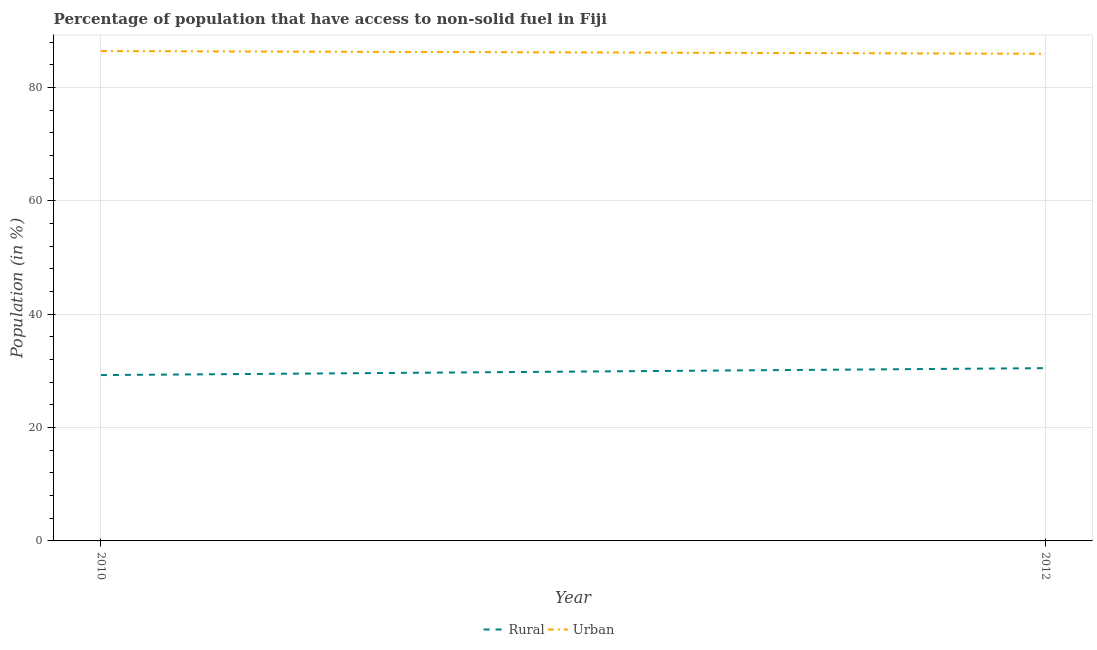How many different coloured lines are there?
Your response must be concise. 2. Does the line corresponding to urban population intersect with the line corresponding to rural population?
Offer a very short reply. No. What is the rural population in 2012?
Provide a succinct answer. 30.49. Across all years, what is the maximum urban population?
Ensure brevity in your answer.  86.44. Across all years, what is the minimum rural population?
Give a very brief answer. 29.26. What is the total rural population in the graph?
Ensure brevity in your answer.  59.75. What is the difference between the rural population in 2010 and that in 2012?
Provide a short and direct response. -1.22. What is the difference between the urban population in 2012 and the rural population in 2010?
Give a very brief answer. 56.7. What is the average rural population per year?
Your answer should be compact. 29.88. In the year 2010, what is the difference between the urban population and rural population?
Give a very brief answer. 57.17. In how many years, is the rural population greater than 16 %?
Give a very brief answer. 2. What is the ratio of the urban population in 2010 to that in 2012?
Ensure brevity in your answer.  1.01. Is the urban population in 2010 less than that in 2012?
Provide a succinct answer. No. In how many years, is the urban population greater than the average urban population taken over all years?
Offer a terse response. 1. Is the urban population strictly less than the rural population over the years?
Ensure brevity in your answer.  No. How many lines are there?
Offer a terse response. 2. How many years are there in the graph?
Ensure brevity in your answer.  2. Are the values on the major ticks of Y-axis written in scientific E-notation?
Provide a short and direct response. No. Does the graph contain grids?
Provide a short and direct response. Yes. How are the legend labels stacked?
Your answer should be compact. Horizontal. What is the title of the graph?
Ensure brevity in your answer.  Percentage of population that have access to non-solid fuel in Fiji. Does "Start a business" appear as one of the legend labels in the graph?
Your answer should be very brief. No. What is the label or title of the Y-axis?
Your answer should be compact. Population (in %). What is the Population (in %) in Rural in 2010?
Ensure brevity in your answer.  29.26. What is the Population (in %) of Urban in 2010?
Make the answer very short. 86.44. What is the Population (in %) of Rural in 2012?
Offer a very short reply. 30.49. What is the Population (in %) of Urban in 2012?
Provide a short and direct response. 85.97. Across all years, what is the maximum Population (in %) in Rural?
Your response must be concise. 30.49. Across all years, what is the maximum Population (in %) of Urban?
Make the answer very short. 86.44. Across all years, what is the minimum Population (in %) of Rural?
Offer a terse response. 29.26. Across all years, what is the minimum Population (in %) in Urban?
Offer a very short reply. 85.97. What is the total Population (in %) in Rural in the graph?
Provide a short and direct response. 59.75. What is the total Population (in %) of Urban in the graph?
Ensure brevity in your answer.  172.41. What is the difference between the Population (in %) of Rural in 2010 and that in 2012?
Give a very brief answer. -1.22. What is the difference between the Population (in %) in Urban in 2010 and that in 2012?
Give a very brief answer. 0.47. What is the difference between the Population (in %) of Rural in 2010 and the Population (in %) of Urban in 2012?
Give a very brief answer. -56.7. What is the average Population (in %) of Rural per year?
Make the answer very short. 29.88. What is the average Population (in %) in Urban per year?
Keep it short and to the point. 86.2. In the year 2010, what is the difference between the Population (in %) in Rural and Population (in %) in Urban?
Your answer should be compact. -57.17. In the year 2012, what is the difference between the Population (in %) in Rural and Population (in %) in Urban?
Make the answer very short. -55.48. What is the ratio of the Population (in %) of Rural in 2010 to that in 2012?
Your answer should be compact. 0.96. What is the difference between the highest and the second highest Population (in %) of Rural?
Your answer should be compact. 1.22. What is the difference between the highest and the second highest Population (in %) in Urban?
Offer a terse response. 0.47. What is the difference between the highest and the lowest Population (in %) of Rural?
Provide a succinct answer. 1.22. What is the difference between the highest and the lowest Population (in %) in Urban?
Ensure brevity in your answer.  0.47. 